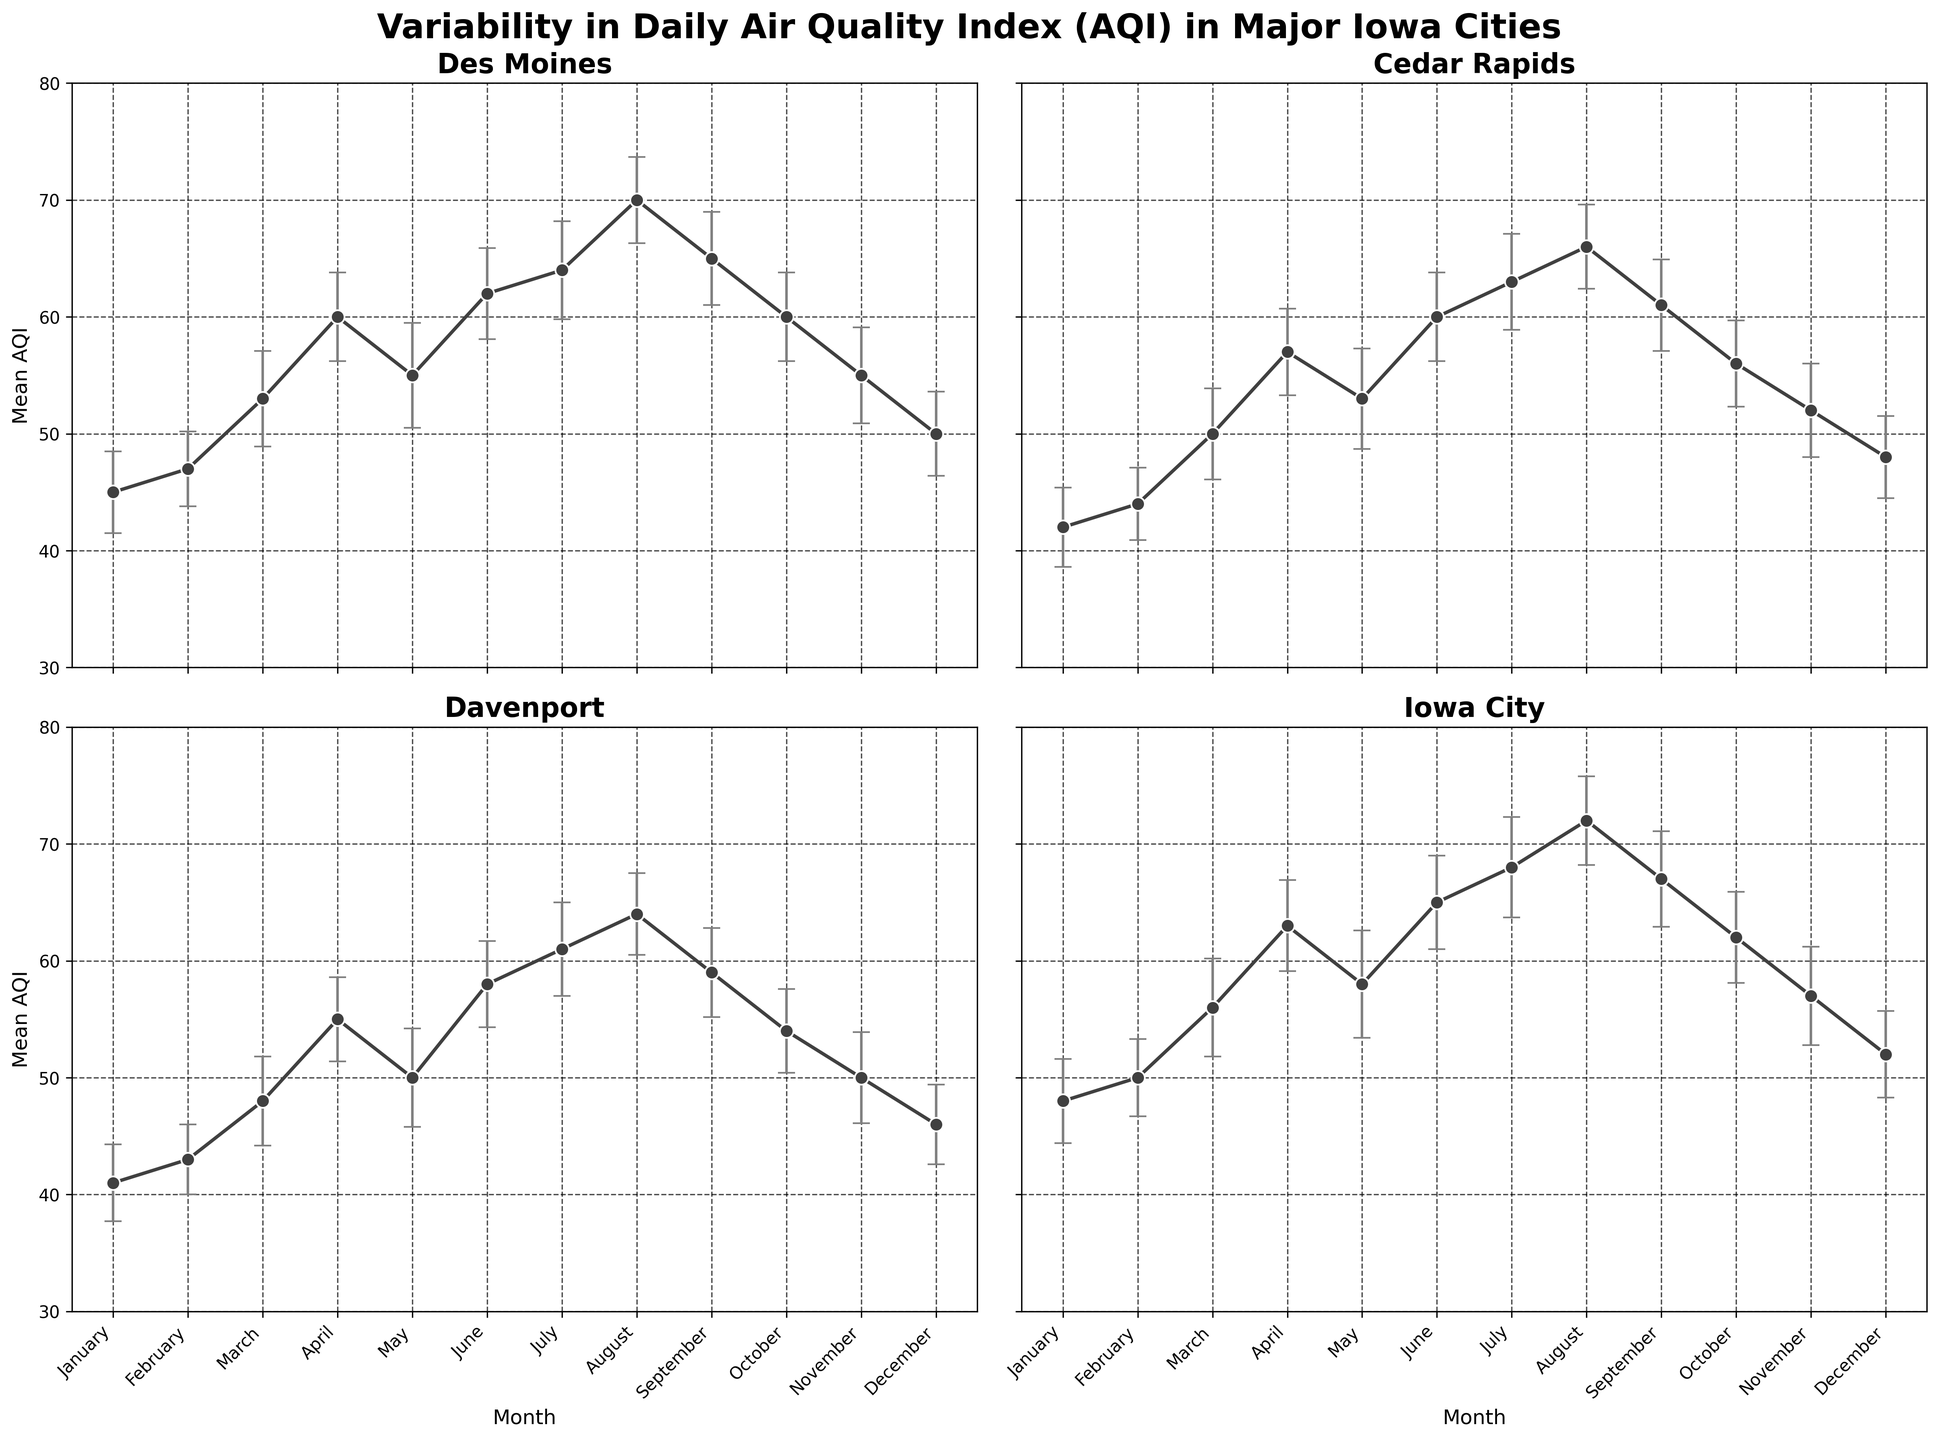Which city has the highest mean AQI in August? To find this, look at the y-values (mean AQI) for each subplot in August. Iowa City has the highest value in August.
Answer: Iowa City What is the range of mean AQI values in Davenport throughout the year? Check the minimum and maximum mean AQI values for Davenport. The minimum is 41 in January, and the maximum is 64 in August. The range is 64 - 41.
Answer: 23 Which month shows the smallest standard error in Cedar Rapids? Observe the error bars (designated by their size) for each month in the Cedar Rapids subplot. February has the smallest error bar.
Answer: February How does the mean AQI in July compare between Des Moines and Iowa City? Compare the y-values (mean AQI) in July for both cities. Des Moines has a mean AQI of 64, while Iowa City has a mean AQI of 68. Iowa City has a higher mean AQI.
Answer: Iowa City has a higher mean AQI What is the overall trend of the mean AQI in Des Moines throughout the year? Look at the line trend in Des Moines' subplot. The AQI generally rises from January to August and then decreases towards December.
Answer: Rising until August, then falling What is the average mean AQI in Cedar Rapids during the summer months (June, July, August)? Sum the mean AQI values in Cedar Rapids for June, July, and August, then divide by 3. (60 + 63 + 66) / 3 = 63.
Answer: 63 Which city experiences the highest variation in monthly mean AQI values? Observe the spread of mean AQI values in all subplots. Iowa City shows the largest variation with values ranging from 48 in January to 72 in August.
Answer: Iowa City Is there any month in which all cities have a similar mean AQI? Compare the mean AQI values across all subplots for each month. In October, all cities have similar mean AQI values around 54-62.
Answer: October What is the mean AQI for Iowa City in November and how does its uncertainty compare to other cities in the same month? Find the mean AQI value for Iowa City in November and compare the standard error bars to those for other cities in November. Iowa City has a mean AQI of 57 with a standard error bar comparable to others.
Answer: 57, comparable uncertainty 